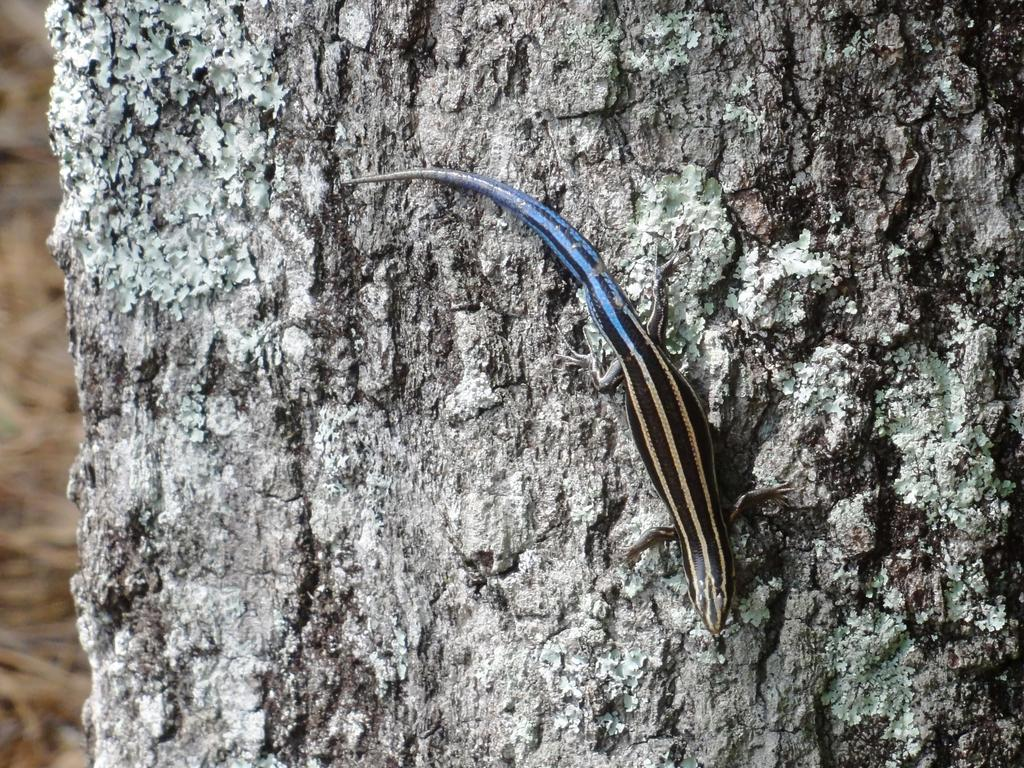What type of animal is in the image? There is a reptile in the image. What colors can be seen on the reptile? The reptile is in black and blue color. Where is the reptile located in the image? The reptile is on a branch. What type of bird is sitting on the reptile's tail in the image? There is no bird present in the image, nor is there a tail on the reptile, as it is a reptile and not a mammal. 